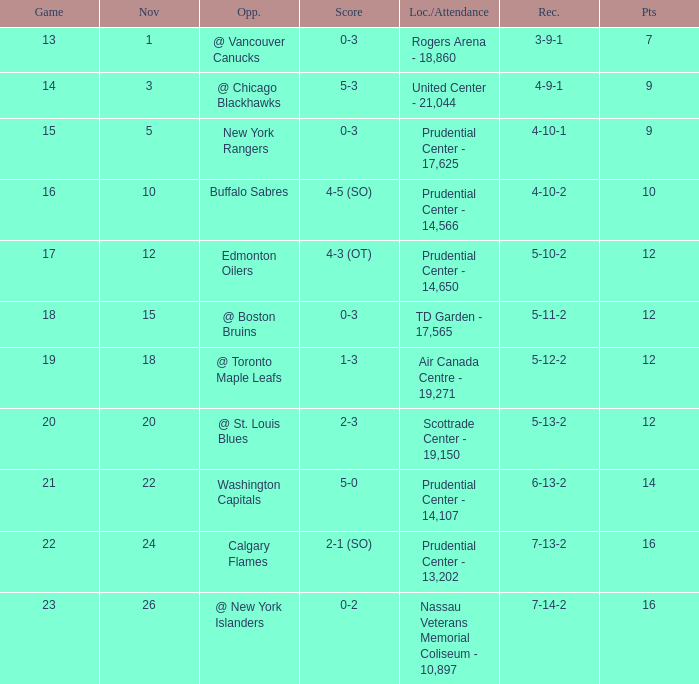What is the count of locations with a rating of 1 to 3? 1.0. Parse the table in full. {'header': ['Game', 'Nov', 'Opp.', 'Score', 'Loc./Attendance', 'Rec.', 'Pts'], 'rows': [['13', '1', '@ Vancouver Canucks', '0-3', 'Rogers Arena - 18,860', '3-9-1', '7'], ['14', '3', '@ Chicago Blackhawks', '5-3', 'United Center - 21,044', '4-9-1', '9'], ['15', '5', 'New York Rangers', '0-3', 'Prudential Center - 17,625', '4-10-1', '9'], ['16', '10', 'Buffalo Sabres', '4-5 (SO)', 'Prudential Center - 14,566', '4-10-2', '10'], ['17', '12', 'Edmonton Oilers', '4-3 (OT)', 'Prudential Center - 14,650', '5-10-2', '12'], ['18', '15', '@ Boston Bruins', '0-3', 'TD Garden - 17,565', '5-11-2', '12'], ['19', '18', '@ Toronto Maple Leafs', '1-3', 'Air Canada Centre - 19,271', '5-12-2', '12'], ['20', '20', '@ St. Louis Blues', '2-3', 'Scottrade Center - 19,150', '5-13-2', '12'], ['21', '22', 'Washington Capitals', '5-0', 'Prudential Center - 14,107', '6-13-2', '14'], ['22', '24', 'Calgary Flames', '2-1 (SO)', 'Prudential Center - 13,202', '7-13-2', '16'], ['23', '26', '@ New York Islanders', '0-2', 'Nassau Veterans Memorial Coliseum - 10,897', '7-14-2', '16']]} 